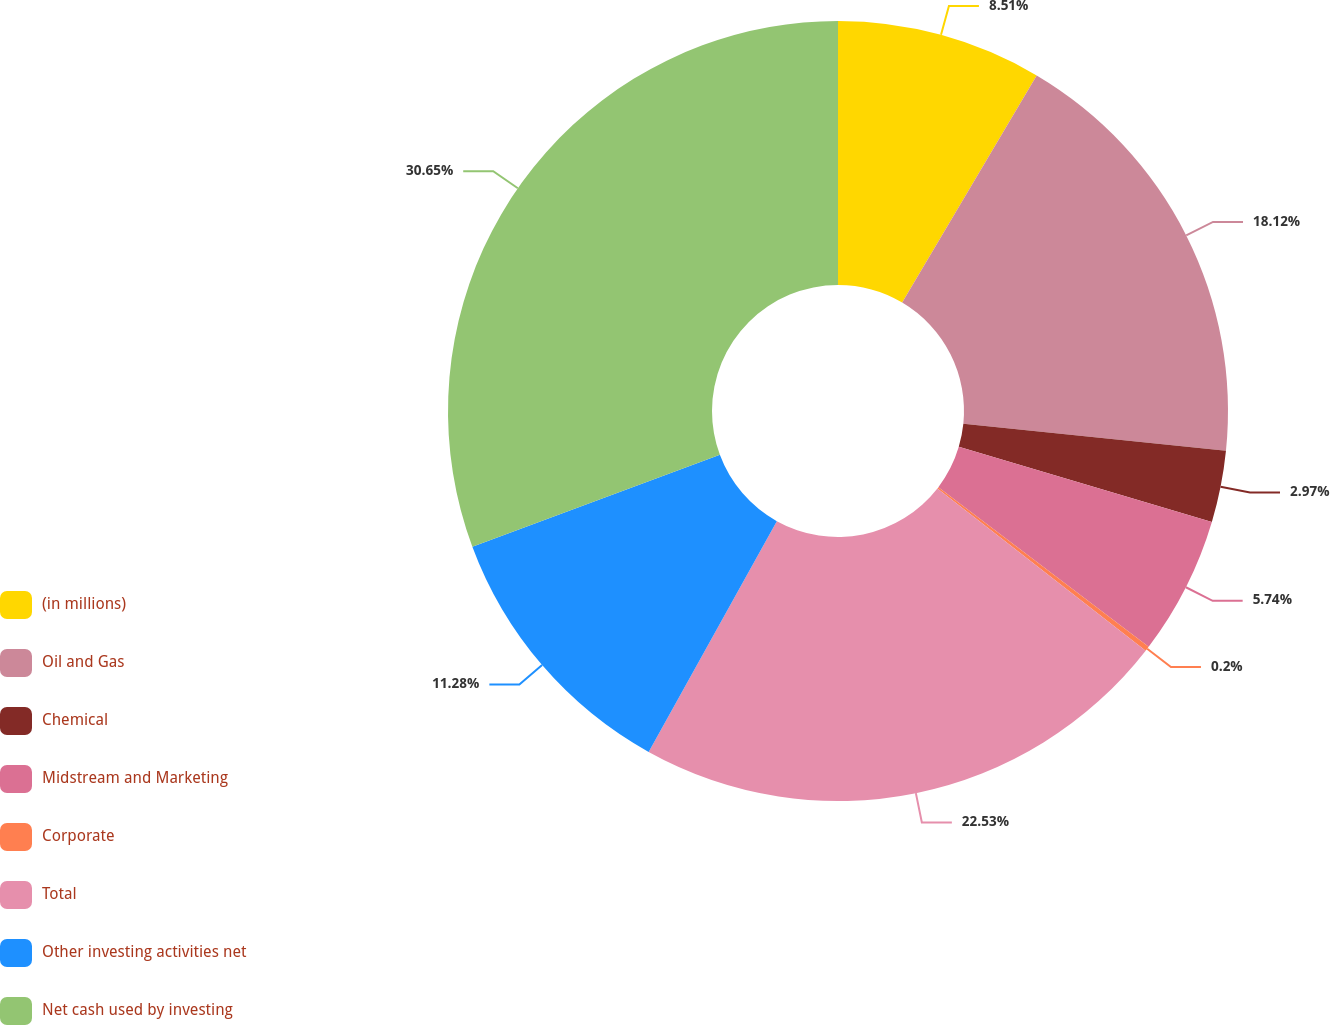Convert chart to OTSL. <chart><loc_0><loc_0><loc_500><loc_500><pie_chart><fcel>(in millions)<fcel>Oil and Gas<fcel>Chemical<fcel>Midstream and Marketing<fcel>Corporate<fcel>Total<fcel>Other investing activities net<fcel>Net cash used by investing<nl><fcel>8.51%<fcel>18.12%<fcel>2.97%<fcel>5.74%<fcel>0.2%<fcel>22.54%<fcel>11.28%<fcel>30.66%<nl></chart> 